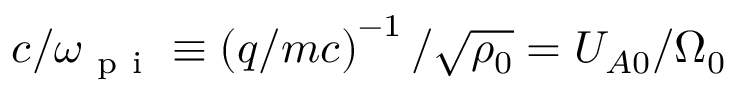Convert formula to latex. <formula><loc_0><loc_0><loc_500><loc_500>c / \omega _ { p i } \equiv \left ( q / m c \right ) ^ { - 1 } / \sqrt { \rho _ { 0 } } = U _ { A 0 } / \Omega _ { 0 }</formula> 